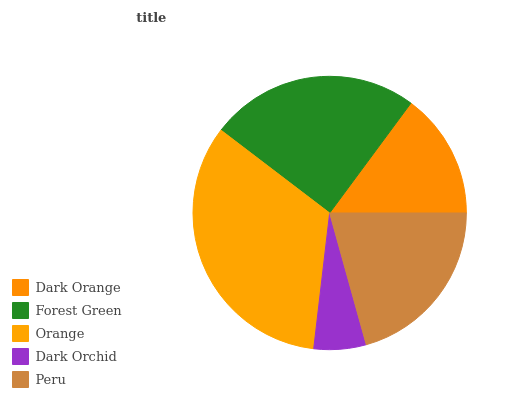Is Dark Orchid the minimum?
Answer yes or no. Yes. Is Orange the maximum?
Answer yes or no. Yes. Is Forest Green the minimum?
Answer yes or no. No. Is Forest Green the maximum?
Answer yes or no. No. Is Forest Green greater than Dark Orange?
Answer yes or no. Yes. Is Dark Orange less than Forest Green?
Answer yes or no. Yes. Is Dark Orange greater than Forest Green?
Answer yes or no. No. Is Forest Green less than Dark Orange?
Answer yes or no. No. Is Peru the high median?
Answer yes or no. Yes. Is Peru the low median?
Answer yes or no. Yes. Is Orange the high median?
Answer yes or no. No. Is Dark Orange the low median?
Answer yes or no. No. 